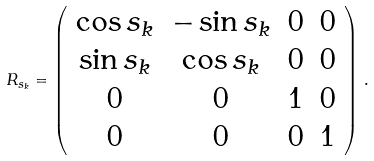Convert formula to latex. <formula><loc_0><loc_0><loc_500><loc_500>R _ { s _ { k } } = \left ( \begin{array} { c c c c } \cos s _ { k } & - \sin s _ { k } & 0 & 0 \\ \sin s _ { k } & \cos s _ { k } & 0 & 0 \\ 0 & 0 & 1 & 0 \\ 0 & 0 & 0 & 1 \end{array} \right ) \, .</formula> 